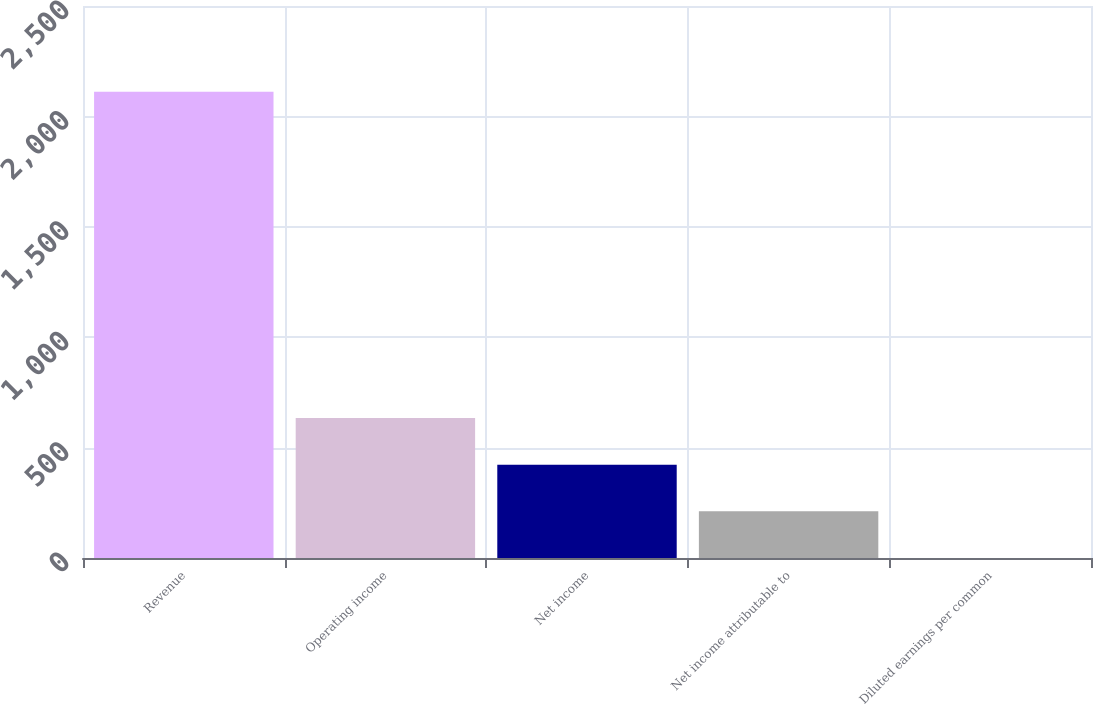<chart> <loc_0><loc_0><loc_500><loc_500><bar_chart><fcel>Revenue<fcel>Operating income<fcel>Net income<fcel>Net income attributable to<fcel>Diluted earnings per common<nl><fcel>2111.7<fcel>633.61<fcel>422.45<fcel>211.3<fcel>0.15<nl></chart> 